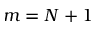<formula> <loc_0><loc_0><loc_500><loc_500>m = N + 1</formula> 